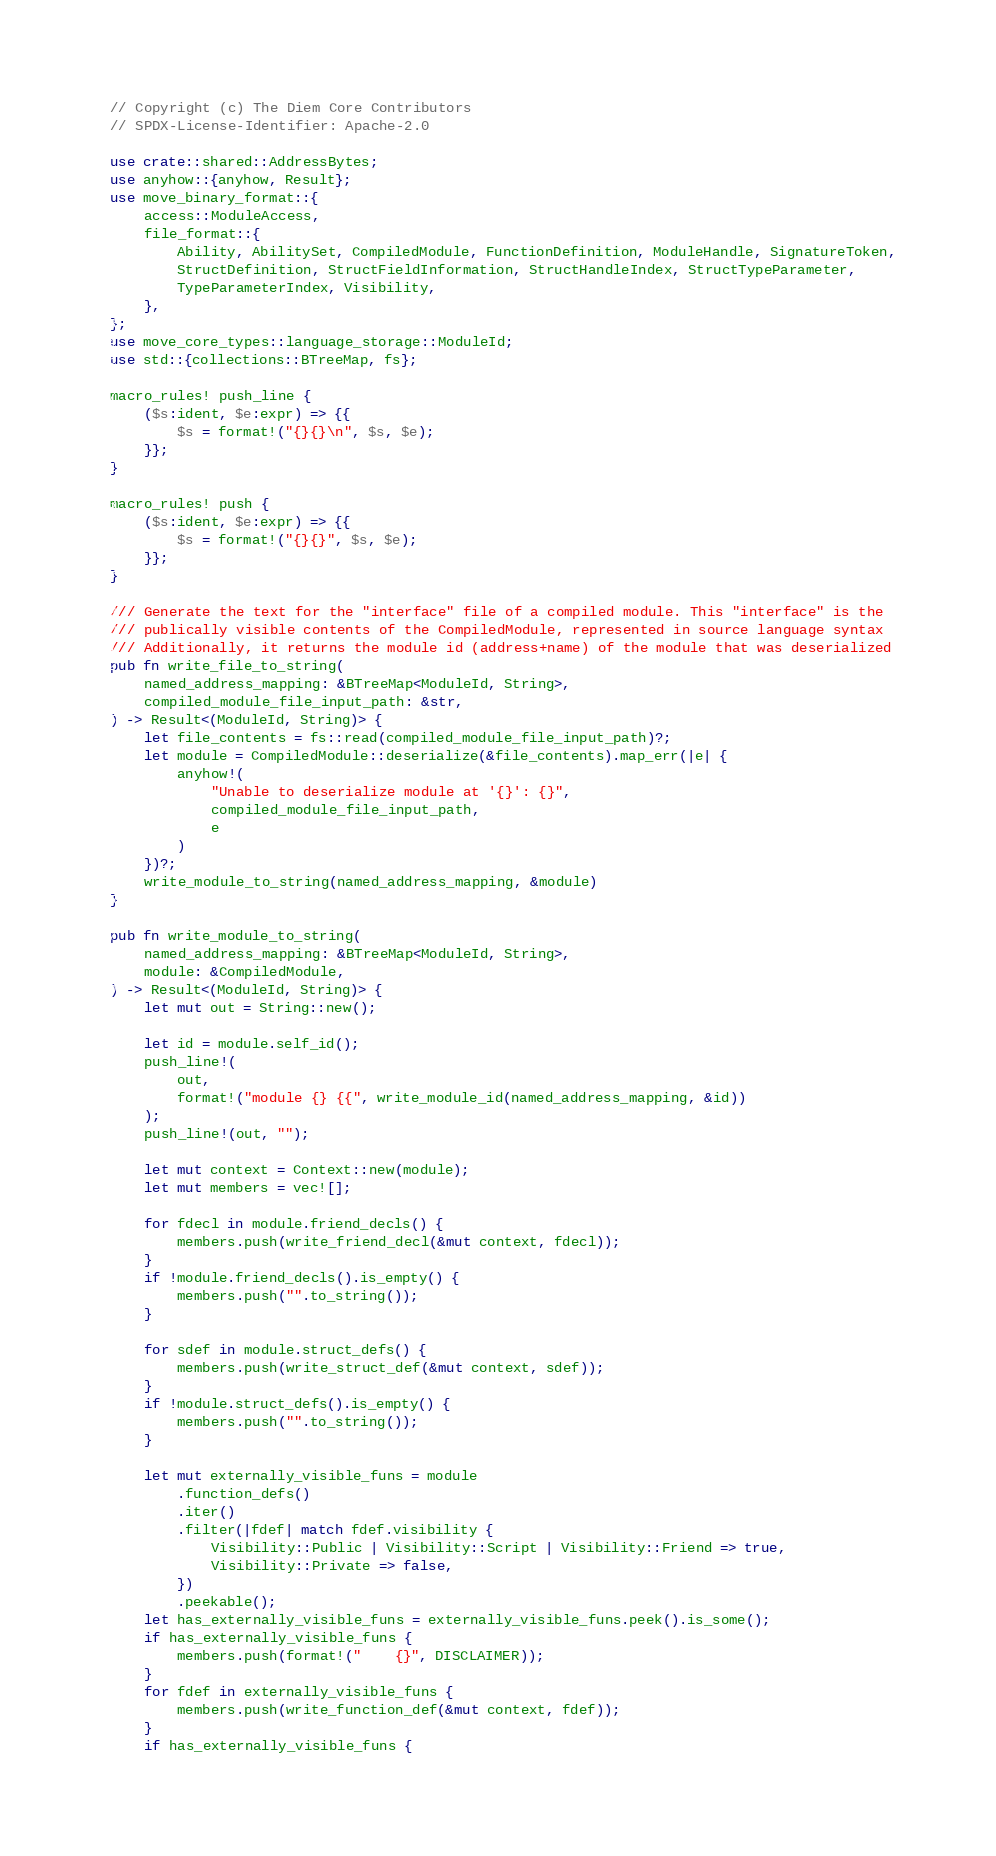<code> <loc_0><loc_0><loc_500><loc_500><_Rust_>// Copyright (c) The Diem Core Contributors
// SPDX-License-Identifier: Apache-2.0

use crate::shared::AddressBytes;
use anyhow::{anyhow, Result};
use move_binary_format::{
    access::ModuleAccess,
    file_format::{
        Ability, AbilitySet, CompiledModule, FunctionDefinition, ModuleHandle, SignatureToken,
        StructDefinition, StructFieldInformation, StructHandleIndex, StructTypeParameter,
        TypeParameterIndex, Visibility,
    },
};
use move_core_types::language_storage::ModuleId;
use std::{collections::BTreeMap, fs};

macro_rules! push_line {
    ($s:ident, $e:expr) => {{
        $s = format!("{}{}\n", $s, $e);
    }};
}

macro_rules! push {
    ($s:ident, $e:expr) => {{
        $s = format!("{}{}", $s, $e);
    }};
}

/// Generate the text for the "interface" file of a compiled module. This "interface" is the
/// publically visible contents of the CompiledModule, represented in source language syntax
/// Additionally, it returns the module id (address+name) of the module that was deserialized
pub fn write_file_to_string(
    named_address_mapping: &BTreeMap<ModuleId, String>,
    compiled_module_file_input_path: &str,
) -> Result<(ModuleId, String)> {
    let file_contents = fs::read(compiled_module_file_input_path)?;
    let module = CompiledModule::deserialize(&file_contents).map_err(|e| {
        anyhow!(
            "Unable to deserialize module at '{}': {}",
            compiled_module_file_input_path,
            e
        )
    })?;
    write_module_to_string(named_address_mapping, &module)
}

pub fn write_module_to_string(
    named_address_mapping: &BTreeMap<ModuleId, String>,
    module: &CompiledModule,
) -> Result<(ModuleId, String)> {
    let mut out = String::new();

    let id = module.self_id();
    push_line!(
        out,
        format!("module {} {{", write_module_id(named_address_mapping, &id))
    );
    push_line!(out, "");

    let mut context = Context::new(module);
    let mut members = vec![];

    for fdecl in module.friend_decls() {
        members.push(write_friend_decl(&mut context, fdecl));
    }
    if !module.friend_decls().is_empty() {
        members.push("".to_string());
    }

    for sdef in module.struct_defs() {
        members.push(write_struct_def(&mut context, sdef));
    }
    if !module.struct_defs().is_empty() {
        members.push("".to_string());
    }

    let mut externally_visible_funs = module
        .function_defs()
        .iter()
        .filter(|fdef| match fdef.visibility {
            Visibility::Public | Visibility::Script | Visibility::Friend => true,
            Visibility::Private => false,
        })
        .peekable();
    let has_externally_visible_funs = externally_visible_funs.peek().is_some();
    if has_externally_visible_funs {
        members.push(format!("    {}", DISCLAIMER));
    }
    for fdef in externally_visible_funs {
        members.push(write_function_def(&mut context, fdef));
    }
    if has_externally_visible_funs {</code> 